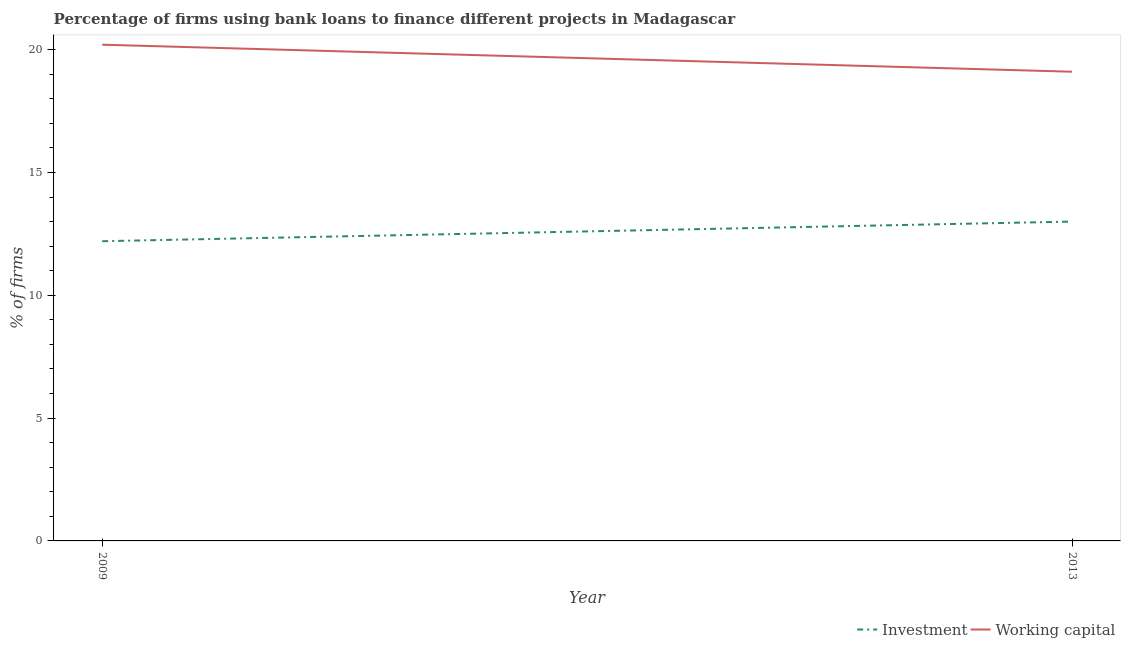Is the number of lines equal to the number of legend labels?
Give a very brief answer. Yes. Across all years, what is the maximum percentage of firms using banks to finance working capital?
Offer a very short reply. 20.2. Across all years, what is the minimum percentage of firms using banks to finance investment?
Your answer should be compact. 12.2. In which year was the percentage of firms using banks to finance investment maximum?
Give a very brief answer. 2013. What is the total percentage of firms using banks to finance working capital in the graph?
Provide a succinct answer. 39.3. What is the difference between the percentage of firms using banks to finance working capital in 2009 and that in 2013?
Give a very brief answer. 1.1. What is the difference between the percentage of firms using banks to finance working capital in 2009 and the percentage of firms using banks to finance investment in 2013?
Make the answer very short. 7.2. What is the average percentage of firms using banks to finance working capital per year?
Your answer should be very brief. 19.65. In the year 2009, what is the difference between the percentage of firms using banks to finance working capital and percentage of firms using banks to finance investment?
Give a very brief answer. 8. In how many years, is the percentage of firms using banks to finance working capital greater than 9 %?
Provide a short and direct response. 2. What is the ratio of the percentage of firms using banks to finance investment in 2009 to that in 2013?
Provide a short and direct response. 0.94. Is the percentage of firms using banks to finance working capital in 2009 less than that in 2013?
Ensure brevity in your answer.  No. In how many years, is the percentage of firms using banks to finance working capital greater than the average percentage of firms using banks to finance working capital taken over all years?
Ensure brevity in your answer.  1. Is the percentage of firms using banks to finance working capital strictly greater than the percentage of firms using banks to finance investment over the years?
Provide a short and direct response. Yes. How many lines are there?
Offer a terse response. 2. What is the difference between two consecutive major ticks on the Y-axis?
Offer a terse response. 5. Are the values on the major ticks of Y-axis written in scientific E-notation?
Provide a short and direct response. No. Does the graph contain any zero values?
Give a very brief answer. No. Does the graph contain grids?
Offer a very short reply. No. How are the legend labels stacked?
Offer a very short reply. Horizontal. What is the title of the graph?
Provide a succinct answer. Percentage of firms using bank loans to finance different projects in Madagascar. Does "Investments" appear as one of the legend labels in the graph?
Provide a short and direct response. No. What is the label or title of the X-axis?
Your answer should be very brief. Year. What is the label or title of the Y-axis?
Provide a succinct answer. % of firms. What is the % of firms of Working capital in 2009?
Your response must be concise. 20.2. What is the % of firms of Working capital in 2013?
Offer a very short reply. 19.1. Across all years, what is the maximum % of firms in Working capital?
Make the answer very short. 20.2. Across all years, what is the minimum % of firms of Investment?
Your answer should be compact. 12.2. What is the total % of firms in Investment in the graph?
Offer a very short reply. 25.2. What is the total % of firms in Working capital in the graph?
Provide a succinct answer. 39.3. What is the difference between the % of firms of Investment in 2009 and that in 2013?
Provide a short and direct response. -0.8. What is the difference between the % of firms in Working capital in 2009 and that in 2013?
Your answer should be compact. 1.1. What is the difference between the % of firms of Investment in 2009 and the % of firms of Working capital in 2013?
Your answer should be compact. -6.9. What is the average % of firms in Investment per year?
Give a very brief answer. 12.6. What is the average % of firms of Working capital per year?
Make the answer very short. 19.65. In the year 2009, what is the difference between the % of firms in Investment and % of firms in Working capital?
Your answer should be compact. -8. In the year 2013, what is the difference between the % of firms in Investment and % of firms in Working capital?
Provide a short and direct response. -6.1. What is the ratio of the % of firms of Investment in 2009 to that in 2013?
Your answer should be compact. 0.94. What is the ratio of the % of firms in Working capital in 2009 to that in 2013?
Keep it short and to the point. 1.06. 